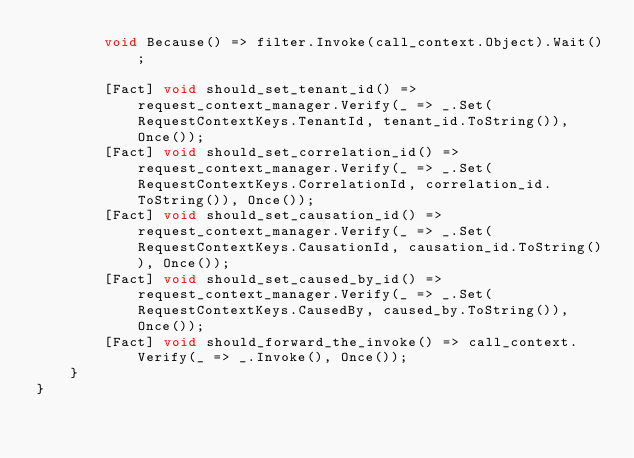Convert code to text. <code><loc_0><loc_0><loc_500><loc_500><_C#_>        void Because() => filter.Invoke(call_context.Object).Wait();

        [Fact] void should_set_tenant_id() => request_context_manager.Verify(_ => _.Set(RequestContextKeys.TenantId, tenant_id.ToString()), Once());
        [Fact] void should_set_correlation_id() => request_context_manager.Verify(_ => _.Set(RequestContextKeys.CorrelationId, correlation_id.ToString()), Once());
        [Fact] void should_set_causation_id() => request_context_manager.Verify(_ => _.Set(RequestContextKeys.CausationId, causation_id.ToString()), Once());
        [Fact] void should_set_caused_by_id() => request_context_manager.Verify(_ => _.Set(RequestContextKeys.CausedBy, caused_by.ToString()), Once());
        [Fact] void should_forward_the_invoke() => call_context.Verify(_ => _.Invoke(), Once());
    }
}
</code> 